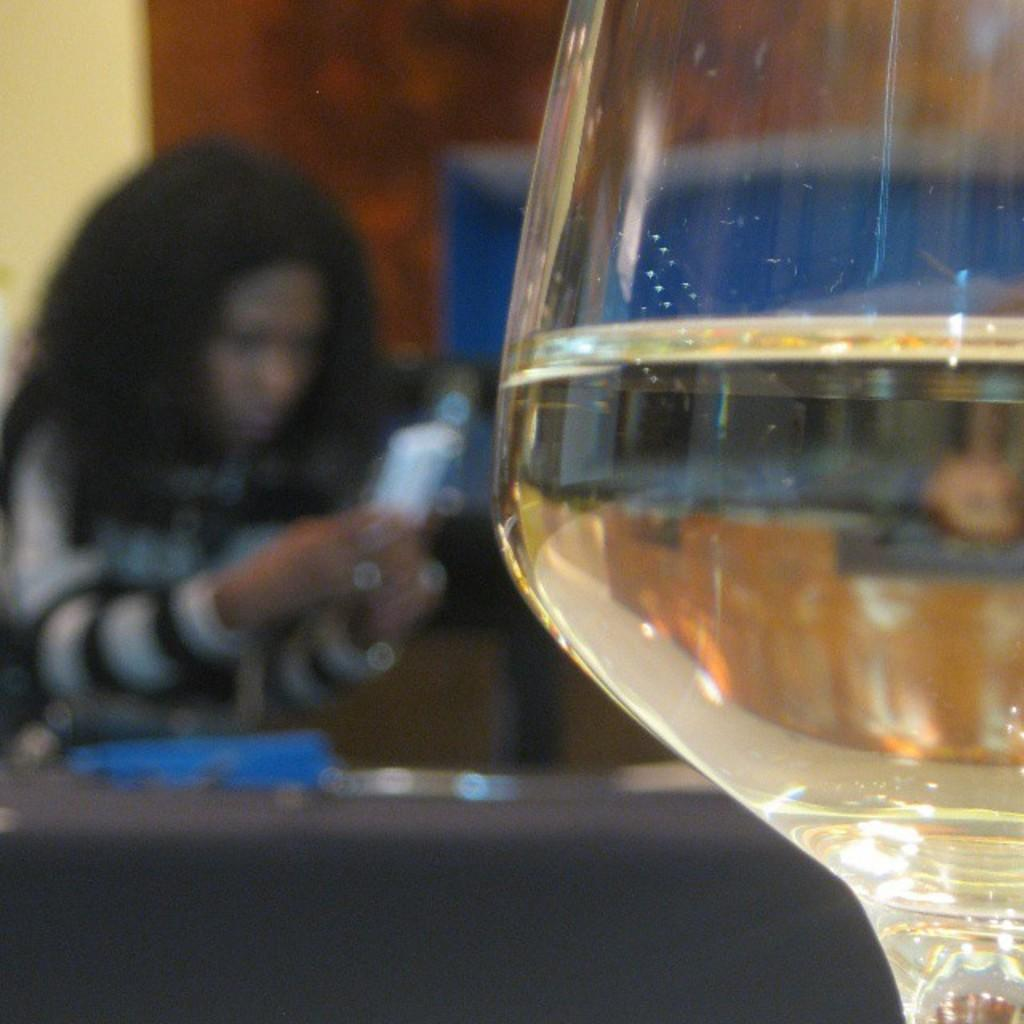What object is visible in the image? There is a glass in the image. Can you describe the setting of the image? The background of the image is blurred, and there is a woman in the background. What is the woman doing in the image? The woman is holding something in her hand. What type of profit can be seen in the image? There is no mention of profit in the image; it features a glass and a woman in the background. 